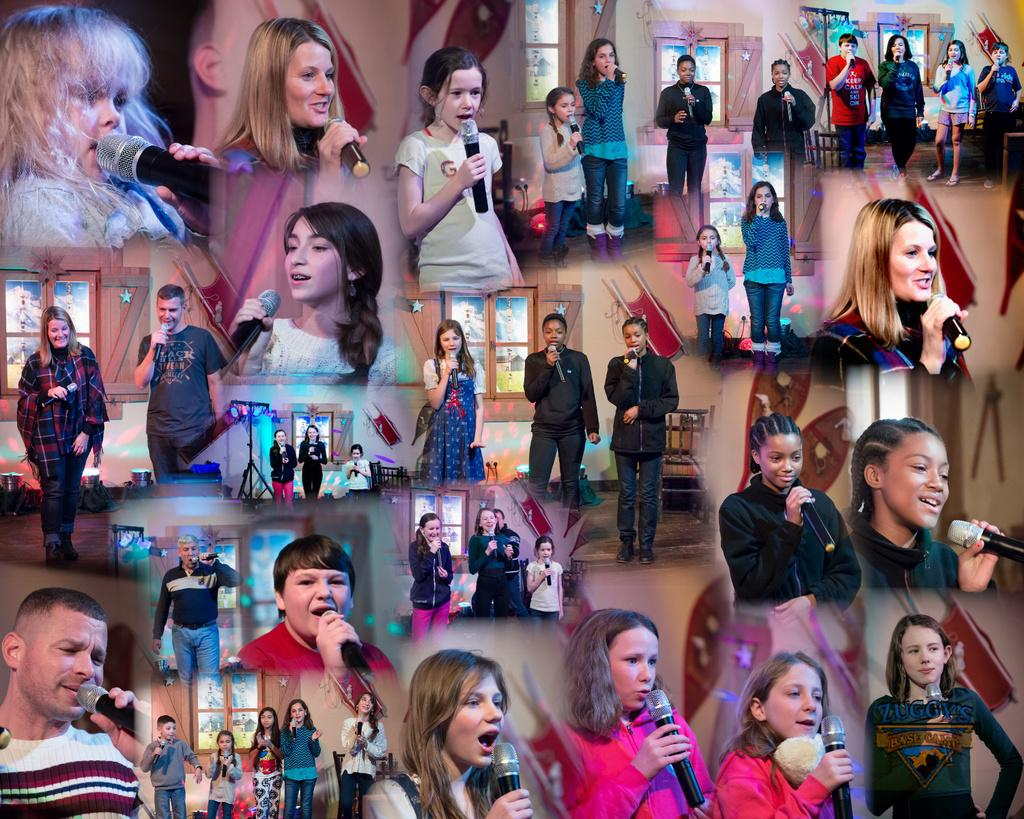What type of images are present in the collection? The images contain pictures of singers. How are the images arranged in the collection? The pictures are arranged together, resembling an album or collection of photos. What type of basket can be seen in the background of the image? There is no basket present in the image; it only contains pictures of singers arranged together. 